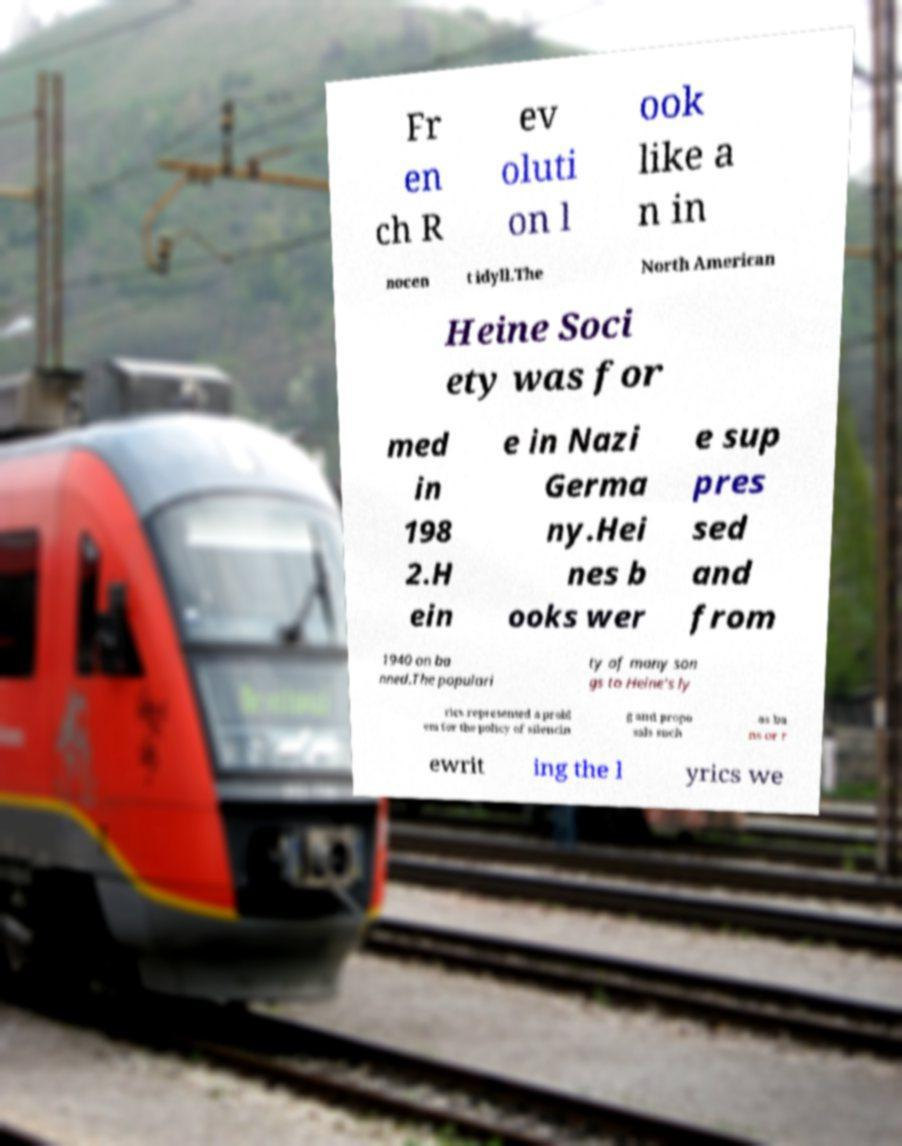Can you read and provide the text displayed in the image?This photo seems to have some interesting text. Can you extract and type it out for me? Fr en ch R ev oluti on l ook like a n in nocen t idyll.The North American Heine Soci ety was for med in 198 2.H ein e in Nazi Germa ny.Hei nes b ooks wer e sup pres sed and from 1940 on ba nned.The populari ty of many son gs to Heine's ly rics represented a probl em for the policy of silencin g and propo sals such as ba ns or r ewrit ing the l yrics we 